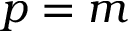<formula> <loc_0><loc_0><loc_500><loc_500>p = m</formula> 